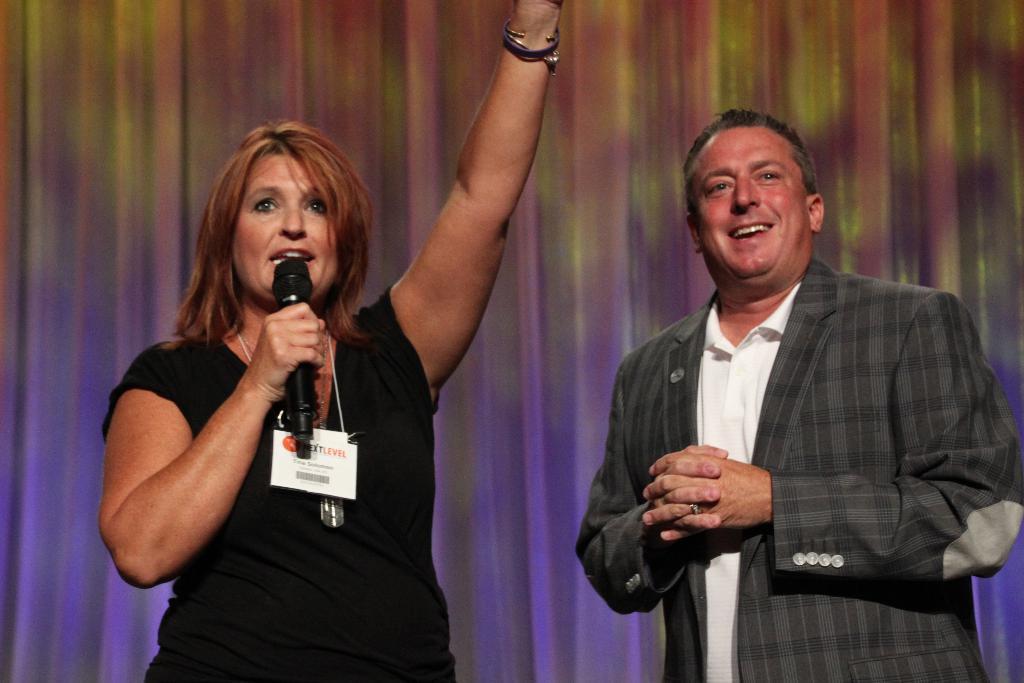Can you describe this image briefly? Here we can see that a woman standing and holding a microphone in her hand, and she is talking and she is wearing an id card, and at beside a man is standing and smiling. 